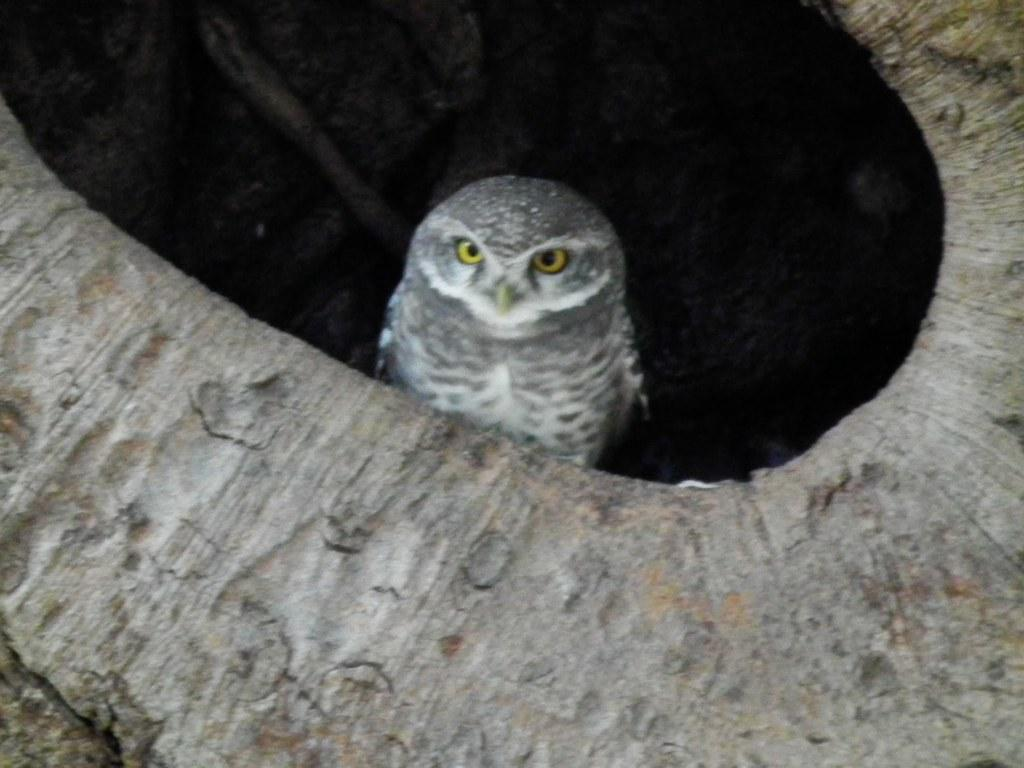What animal is present in the image? There is an owl in the image. Where is the owl located? The owl is standing inside a tree trunk. What is the color of the background in the image? The background of the image appears dark in color. What type of loaf is being prepared on the stove in the image? There is no stove or loaf present in the image; it features an owl standing inside a tree trunk with a dark background. 